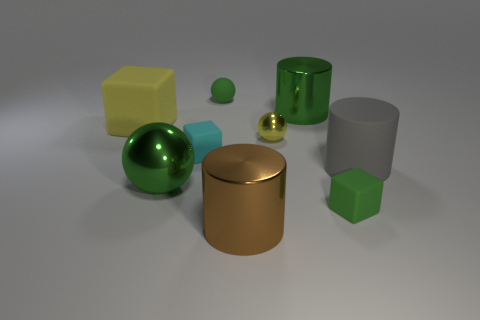What is the sphere that is behind the large yellow cube made of?
Provide a succinct answer. Rubber. How many big objects are either red rubber cubes or yellow balls?
Your answer should be very brief. 0. There is a cylinder that is in front of the green metal sphere; is its size the same as the tiny yellow thing?
Your response must be concise. No. How many other objects are the same color as the small metal thing?
Offer a very short reply. 1. What is the material of the green block?
Give a very brief answer. Rubber. What is the material of the cube that is on the right side of the large shiny ball and left of the small green rubber cube?
Offer a terse response. Rubber. What number of objects are either big yellow matte objects that are in front of the big green cylinder or balls?
Your answer should be very brief. 4. Do the small metal sphere and the large cube have the same color?
Your answer should be compact. Yes. Is there a cyan object of the same size as the cyan block?
Offer a very short reply. No. How many matte objects are behind the tiny green matte cube and to the right of the tiny green sphere?
Provide a succinct answer. 1. 